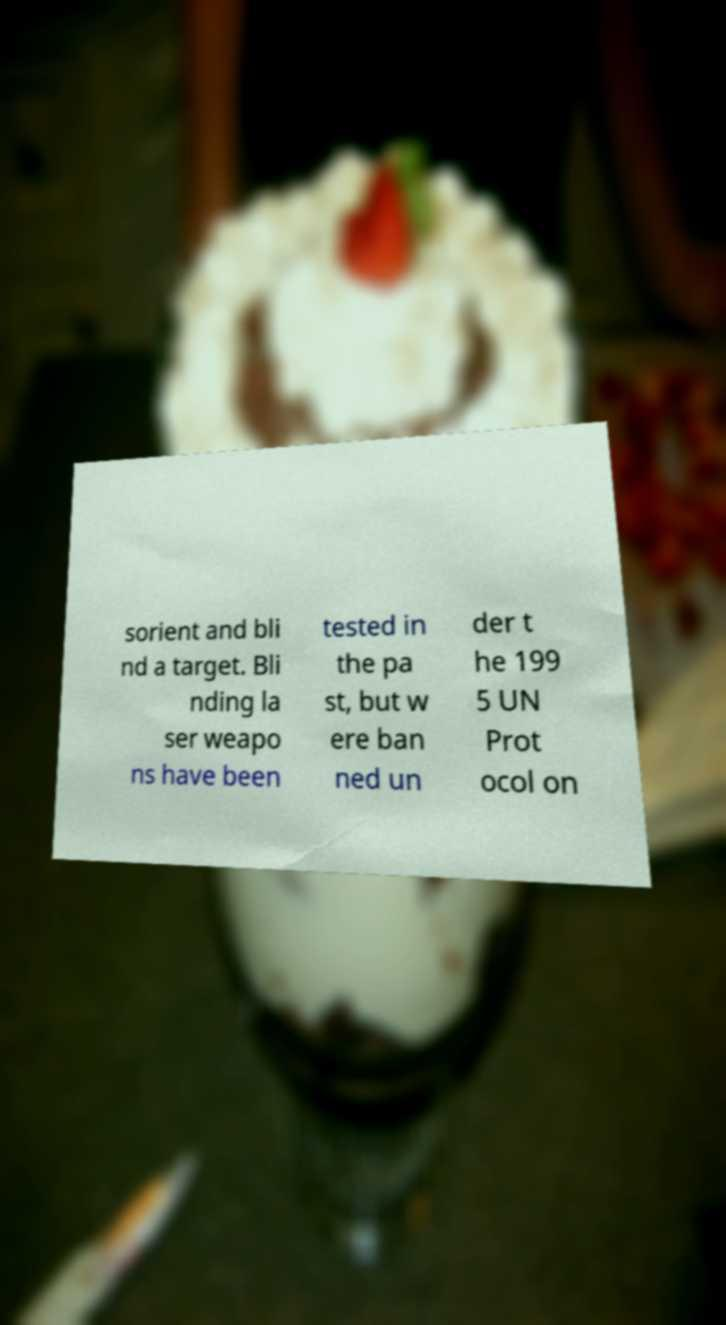Could you extract and type out the text from this image? sorient and bli nd a target. Bli nding la ser weapo ns have been tested in the pa st, but w ere ban ned un der t he 199 5 UN Prot ocol on 